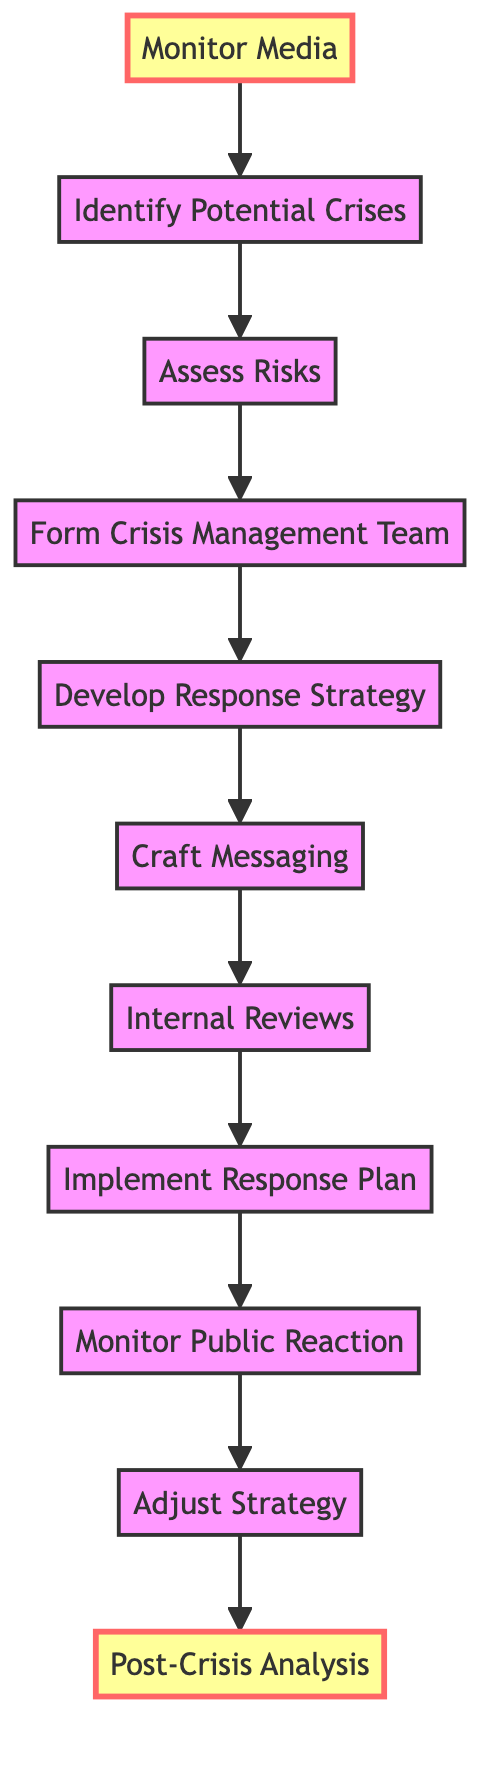What is the first step in the crisis management plan? According to the diagram, the first node in the directed graph represents the first step, which is labeled "Monitor Media."
Answer: Monitor Media How many steps are there in the process? The diagram shows 11 nodes, each representing a step in the process, making the total number of steps 11.
Answer: 11 What step follows the assessment of risks? From the arrow connection in the diagram, after "Assess Risks," the next step is "Form Crisis Management Team."
Answer: Form Crisis Management Team Which step is directly before "Implement Response Plan"? By examining the directed edges, it shows that "Internal Reviews" directly precedes "Implement Response Plan."
Answer: Internal Reviews What is the last step in the crisis management plan? The final node in the directed graph indicates that the last step is "Post-Crisis Analysis."
Answer: Post-Crisis Analysis How many edges connect the steps in this plan? The diagram has 10 edges connecting each of the 11 steps, forming a sequential pathway through the process.
Answer: 10 What is the relationship between "Craft Messaging" and "Internal Reviews"? The diagram shows a directed connection from "Craft Messaging" to "Internal Reviews," meaning "Craft Messaging" leads to "Internal Reviews."
Answer: "Craft Messaging" leads to "Internal Reviews" Which two steps follow "Monitor Public Reaction"? The directed edges indicate that two steps follow "Monitor Public Reaction," which are "Adjust Strategy" and "Post-Crisis Analysis."
Answer: Adjust Strategy, Post-Crisis Analysis How does the diagram represent the step of risk assessment? The node labeled "Assess Risks" is specifically designed to indicate the step of risk assessment in the process.
Answer: Assess Risks 